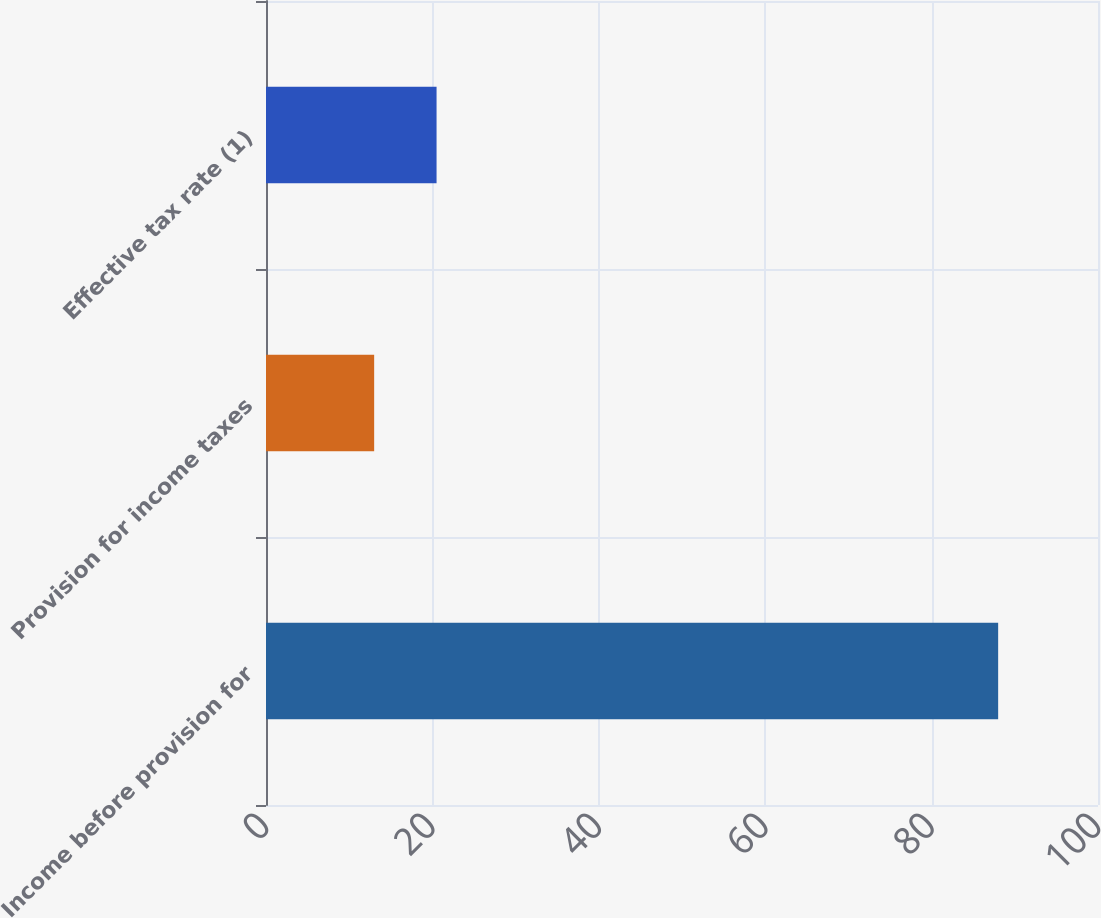Convert chart to OTSL. <chart><loc_0><loc_0><loc_500><loc_500><bar_chart><fcel>Income before provision for<fcel>Provision for income taxes<fcel>Effective tax rate (1)<nl><fcel>88<fcel>13<fcel>20.5<nl></chart> 